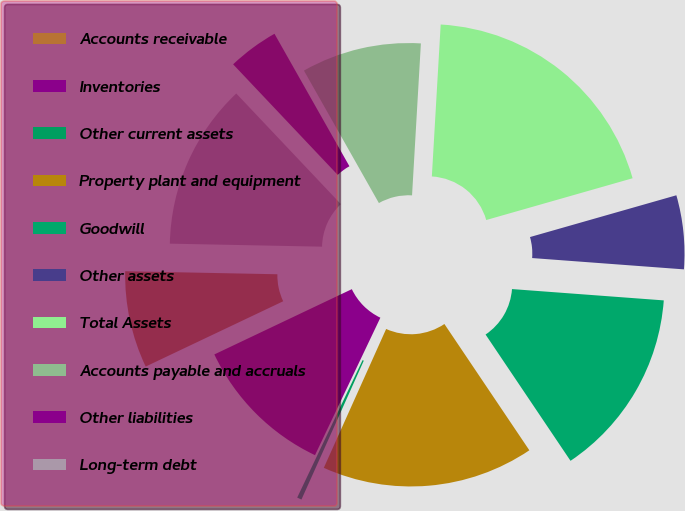<chart> <loc_0><loc_0><loc_500><loc_500><pie_chart><fcel>Accounts receivable<fcel>Inventories<fcel>Other current assets<fcel>Property plant and equipment<fcel>Goodwill<fcel>Other assets<fcel>Total Assets<fcel>Accounts payable and accruals<fcel>Other liabilities<fcel>Long-term debt<nl><fcel>7.37%<fcel>10.88%<fcel>0.35%<fcel>16.14%<fcel>14.39%<fcel>5.61%<fcel>19.65%<fcel>9.12%<fcel>3.86%<fcel>12.63%<nl></chart> 